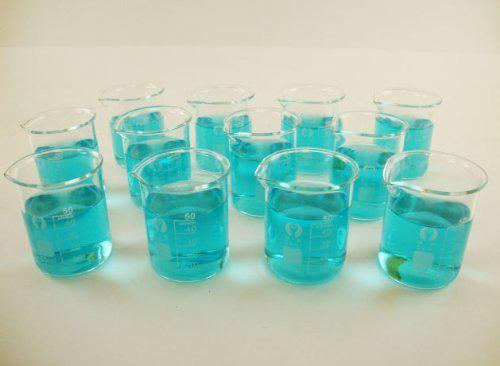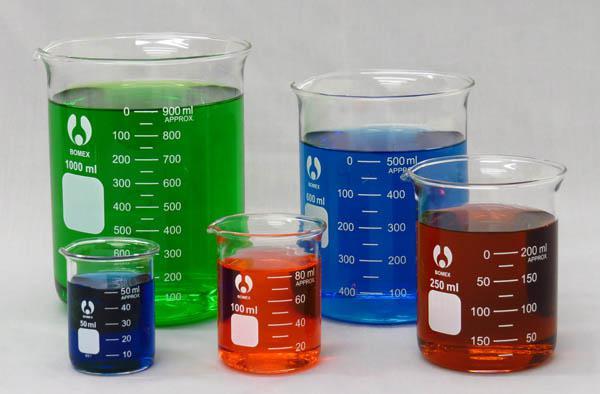The first image is the image on the left, the second image is the image on the right. Given the left and right images, does the statement "At least one of the containers in one of the images is empty." hold true? Answer yes or no. No. The first image is the image on the left, the second image is the image on the right. Examine the images to the left and right. Is the description "The containers in the left image are empty." accurate? Answer yes or no. No. 